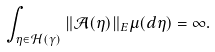Convert formula to latex. <formula><loc_0><loc_0><loc_500><loc_500>\int _ { \eta \in \mathcal { H } ( \gamma ) } \| \mathcal { A } ( \eta ) \| _ { E } \mu ( d \eta ) = \infty .</formula> 